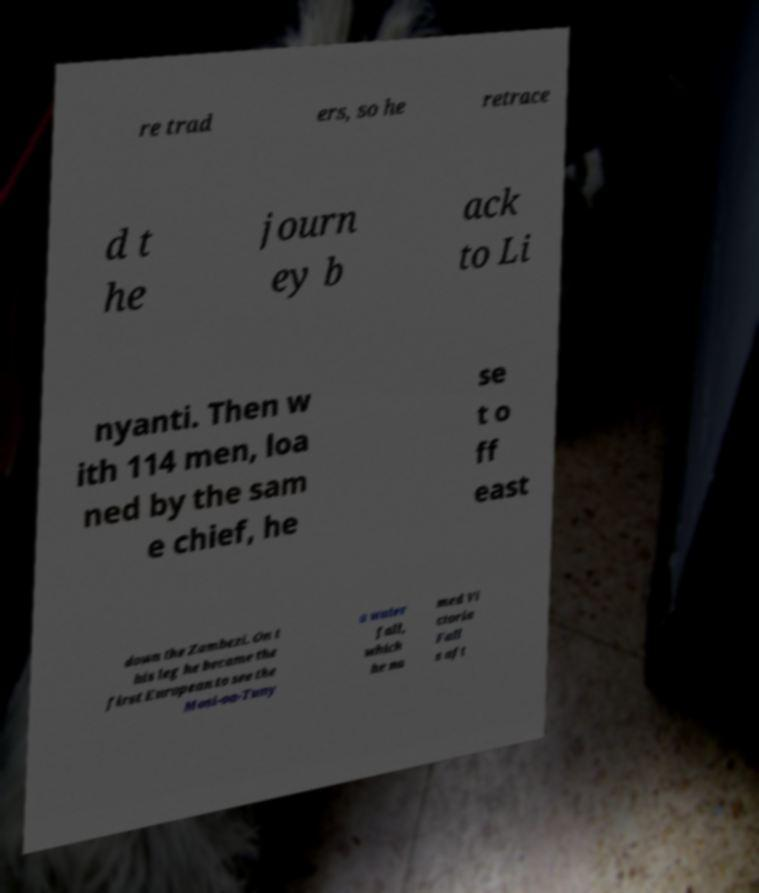What messages or text are displayed in this image? I need them in a readable, typed format. re trad ers, so he retrace d t he journ ey b ack to Li nyanti. Then w ith 114 men, loa ned by the sam e chief, he se t o ff east down the Zambezi. On t his leg he became the first European to see the Mosi-oa-Tuny a water fall, which he na med Vi ctoria Fall s aft 